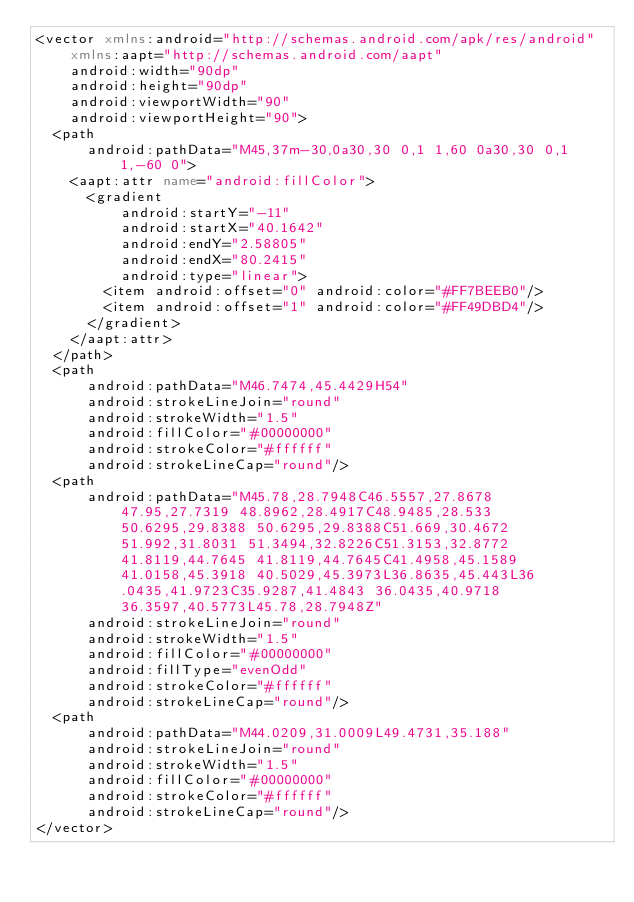Convert code to text. <code><loc_0><loc_0><loc_500><loc_500><_XML_><vector xmlns:android="http://schemas.android.com/apk/res/android"
    xmlns:aapt="http://schemas.android.com/aapt"
    android:width="90dp"
    android:height="90dp"
    android:viewportWidth="90"
    android:viewportHeight="90">
  <path
      android:pathData="M45,37m-30,0a30,30 0,1 1,60 0a30,30 0,1 1,-60 0">
    <aapt:attr name="android:fillColor">
      <gradient 
          android:startY="-11"
          android:startX="40.1642"
          android:endY="2.58805"
          android:endX="80.2415"
          android:type="linear">
        <item android:offset="0" android:color="#FF7BEEB0"/>
        <item android:offset="1" android:color="#FF49DBD4"/>
      </gradient>
    </aapt:attr>
  </path>
  <path
      android:pathData="M46.7474,45.4429H54"
      android:strokeLineJoin="round"
      android:strokeWidth="1.5"
      android:fillColor="#00000000"
      android:strokeColor="#ffffff"
      android:strokeLineCap="round"/>
  <path
      android:pathData="M45.78,28.7948C46.5557,27.8678 47.95,27.7319 48.8962,28.4917C48.9485,28.533 50.6295,29.8388 50.6295,29.8388C51.669,30.4672 51.992,31.8031 51.3494,32.8226C51.3153,32.8772 41.8119,44.7645 41.8119,44.7645C41.4958,45.1589 41.0158,45.3918 40.5029,45.3973L36.8635,45.443L36.0435,41.9723C35.9287,41.4843 36.0435,40.9718 36.3597,40.5773L45.78,28.7948Z"
      android:strokeLineJoin="round"
      android:strokeWidth="1.5"
      android:fillColor="#00000000"
      android:fillType="evenOdd"
      android:strokeColor="#ffffff"
      android:strokeLineCap="round"/>
  <path
      android:pathData="M44.0209,31.0009L49.4731,35.188"
      android:strokeLineJoin="round"
      android:strokeWidth="1.5"
      android:fillColor="#00000000"
      android:strokeColor="#ffffff"
      android:strokeLineCap="round"/>
</vector>
</code> 